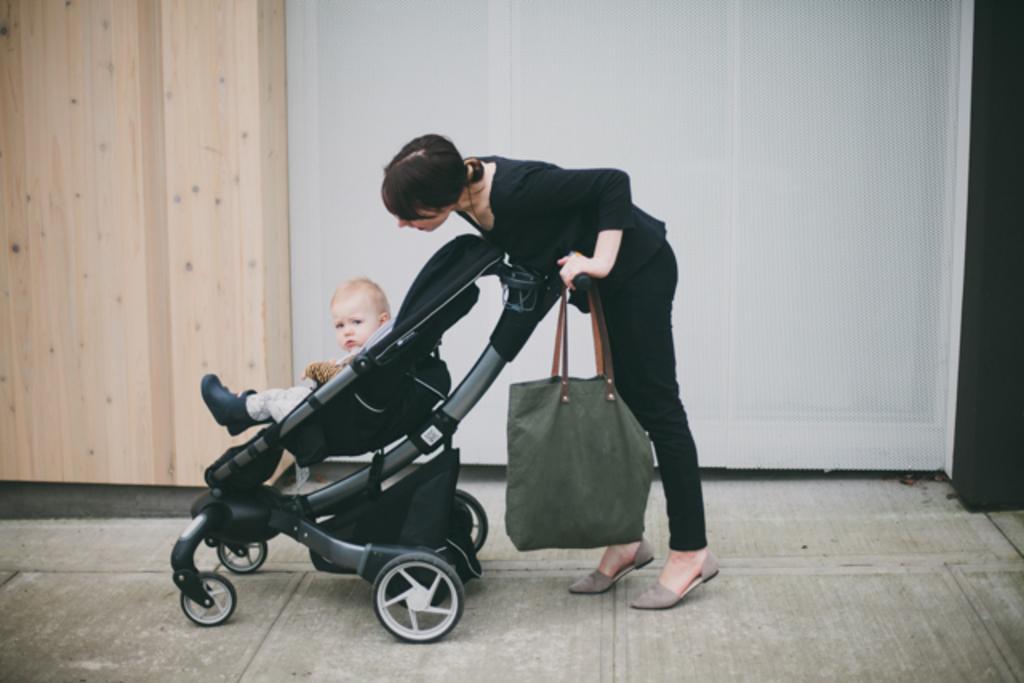How would you summarize this image in a sentence or two? In this picture we can see woman standing and holding stroller with her hand where we have a child on it and bag is hanged to it and in background we can see wall and they are on the floor. 